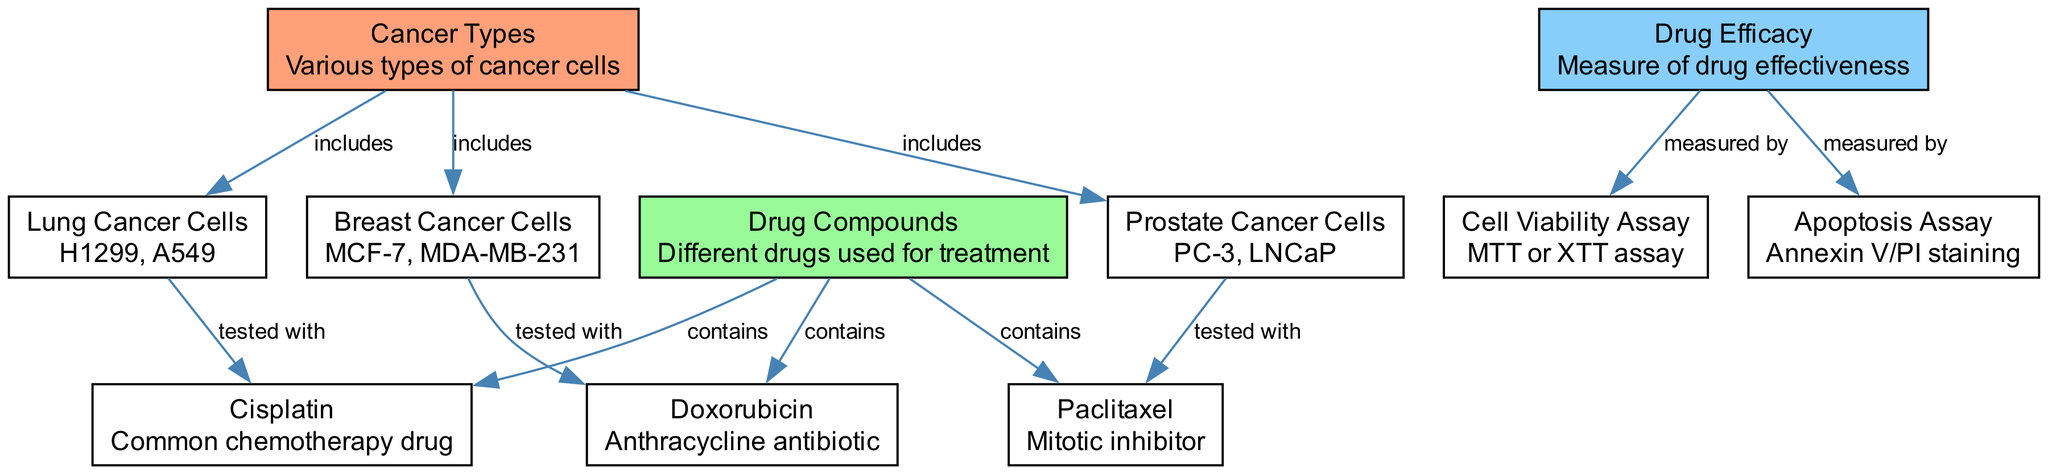What types of cancer cells are included in the diagram? The diagram specifies three types of cancer cells: Lung Cancer Cells, Breast Cancer Cells, and Prostate Cancer Cells. These are directly linked to the "Cancer Types" node with the relationship "includes."
Answer: Lung Cancer Cells, Breast Cancer Cells, Prostate Cancer Cells How many drug compounds are depicted in the diagram? The diagram includes three drug compounds (Cisplatin, Doxorubicin, and Paclitaxel). This is indicated under the node "Drug Compounds," which contains all three compounds.
Answer: 3 Which assay is used to measure drug efficacy? The diagram shows that drug efficacy is measured by both the Cell Viability Assay and the Apoptosis Assay. The edges indicate that both assays are linked to the "Drug Efficacy" node through the relationship "measured by."
Answer: Cell Viability Assay, Apoptosis Assay What type of cancer cells is tested with Cisplatin? To find this, we look for the edge connecting "Lung Cancer Cells" to "Cisplatin," which shows that specifically, Lung Cancer Cells are tested with Cisplatin in the diagram.
Answer: Lung Cancer Cells Which drug is tested with Breast Cancer Cells? By checking the edges, we find that Doxorubicin is linked to Breast Cancer Cells, indicating it is tested with this type of cancer cells.
Answer: Doxorubicin How many relationships (edges) are there in the diagram? By counting the edges listed, we see that there are a total of 10 edges connecting various nodes. This represents the relationships between cancer types, drug compounds, and efficacy measures.
Answer: 10 Which drug compound is associated with the Prostate Cancer Cells? The diagram clearly shows that Paclitaxel is tested with Prostate Cancer Cells through the edge connecting those nodes, representing the association.
Answer: Paclitaxel What relationship exists between Drug Compounds and Cancer Types? The direct relationships are represented by edges that indicate Drug Compounds are "tested with" the specific types of Cancer Cells. This explains the relationship between these two categories in the diagram.
Answer: tested with 